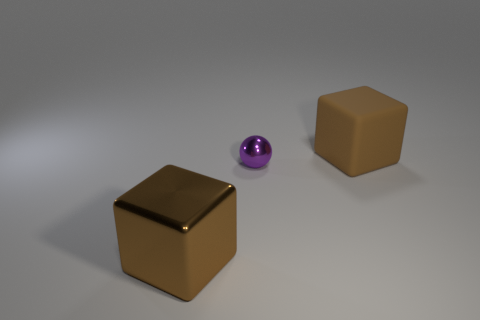Add 3 small metal blocks. How many objects exist? 6 Subtract all cubes. How many objects are left? 1 Subtract 1 cubes. How many cubes are left? 1 Subtract all small gray shiny blocks. Subtract all matte objects. How many objects are left? 2 Add 1 small things. How many small things are left? 2 Add 3 large rubber blocks. How many large rubber blocks exist? 4 Subtract 0 blue blocks. How many objects are left? 3 Subtract all red balls. Subtract all blue cylinders. How many balls are left? 1 Subtract all yellow spheres. How many yellow blocks are left? 0 